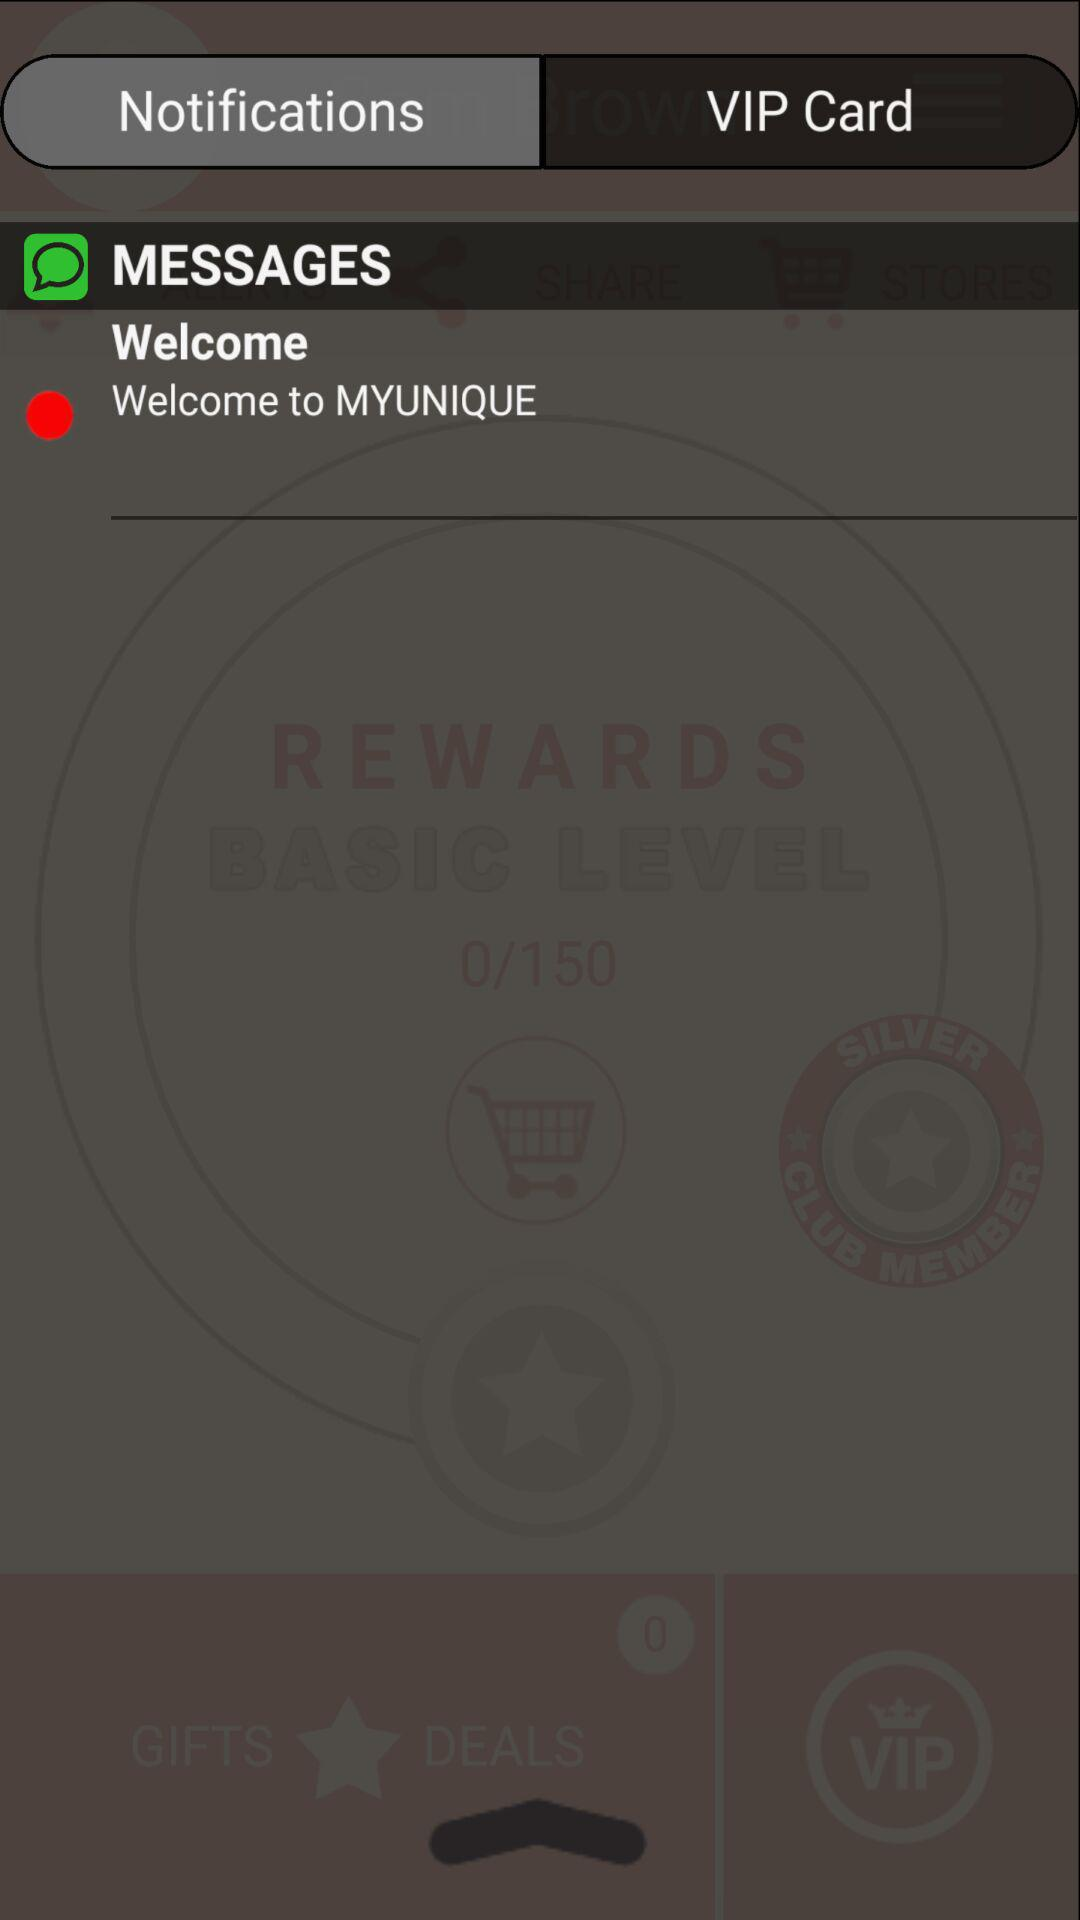How many more points are required to reach the next rewards level?
Answer the question using a single word or phrase. 150 